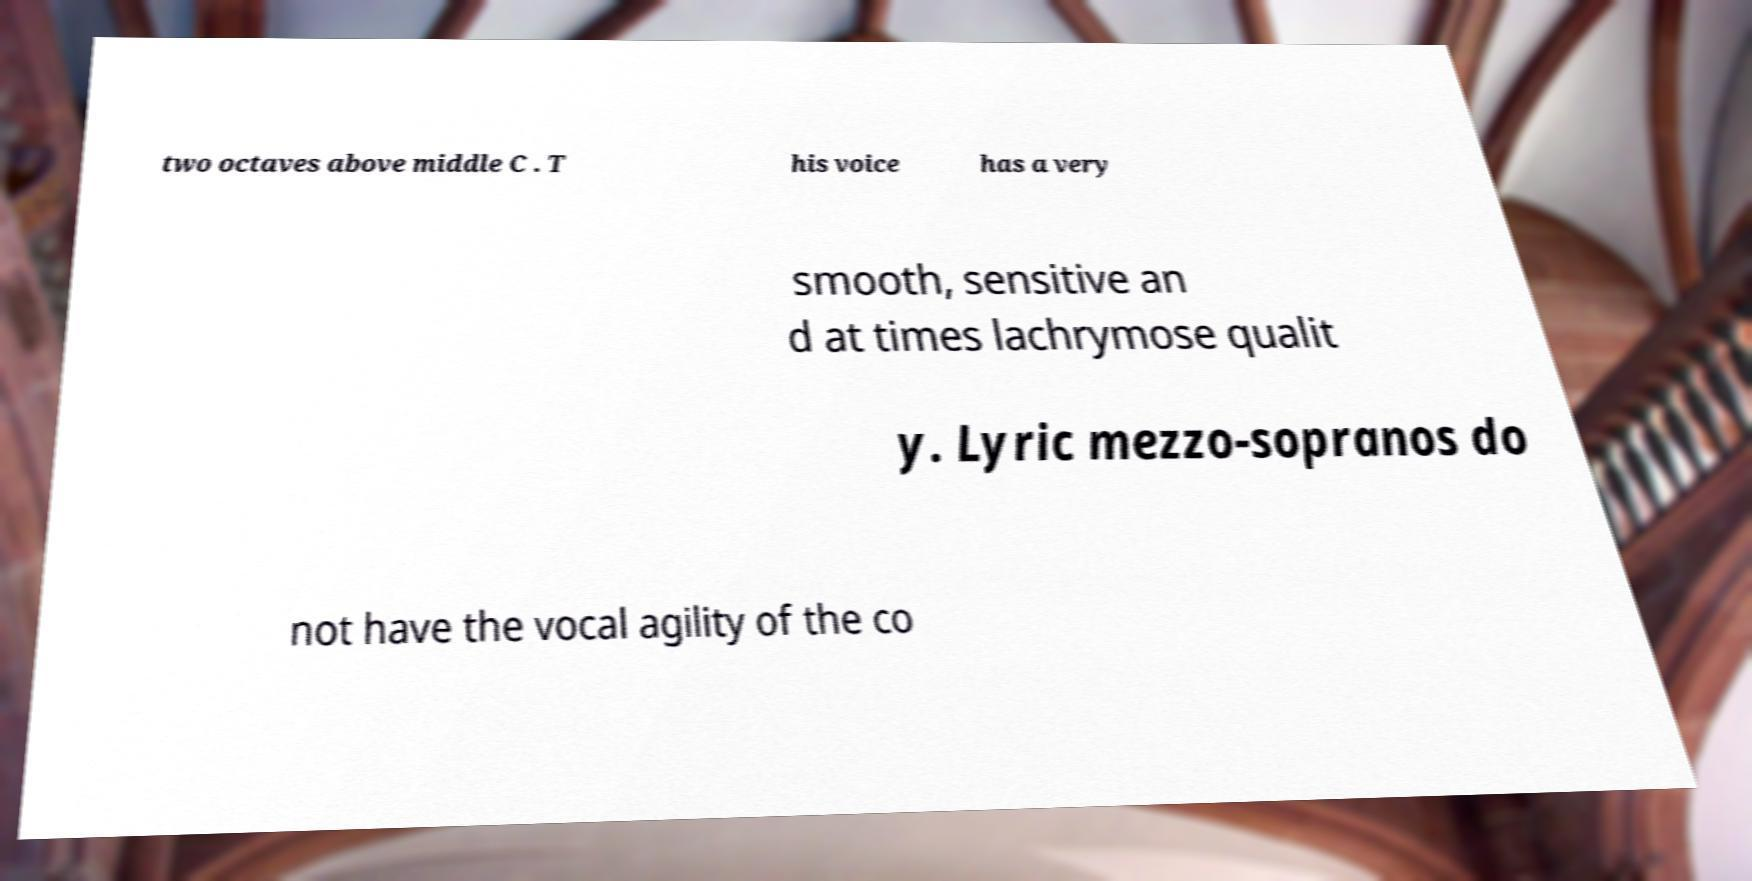What messages or text are displayed in this image? I need them in a readable, typed format. two octaves above middle C . T his voice has a very smooth, sensitive an d at times lachrymose qualit y. Lyric mezzo-sopranos do not have the vocal agility of the co 